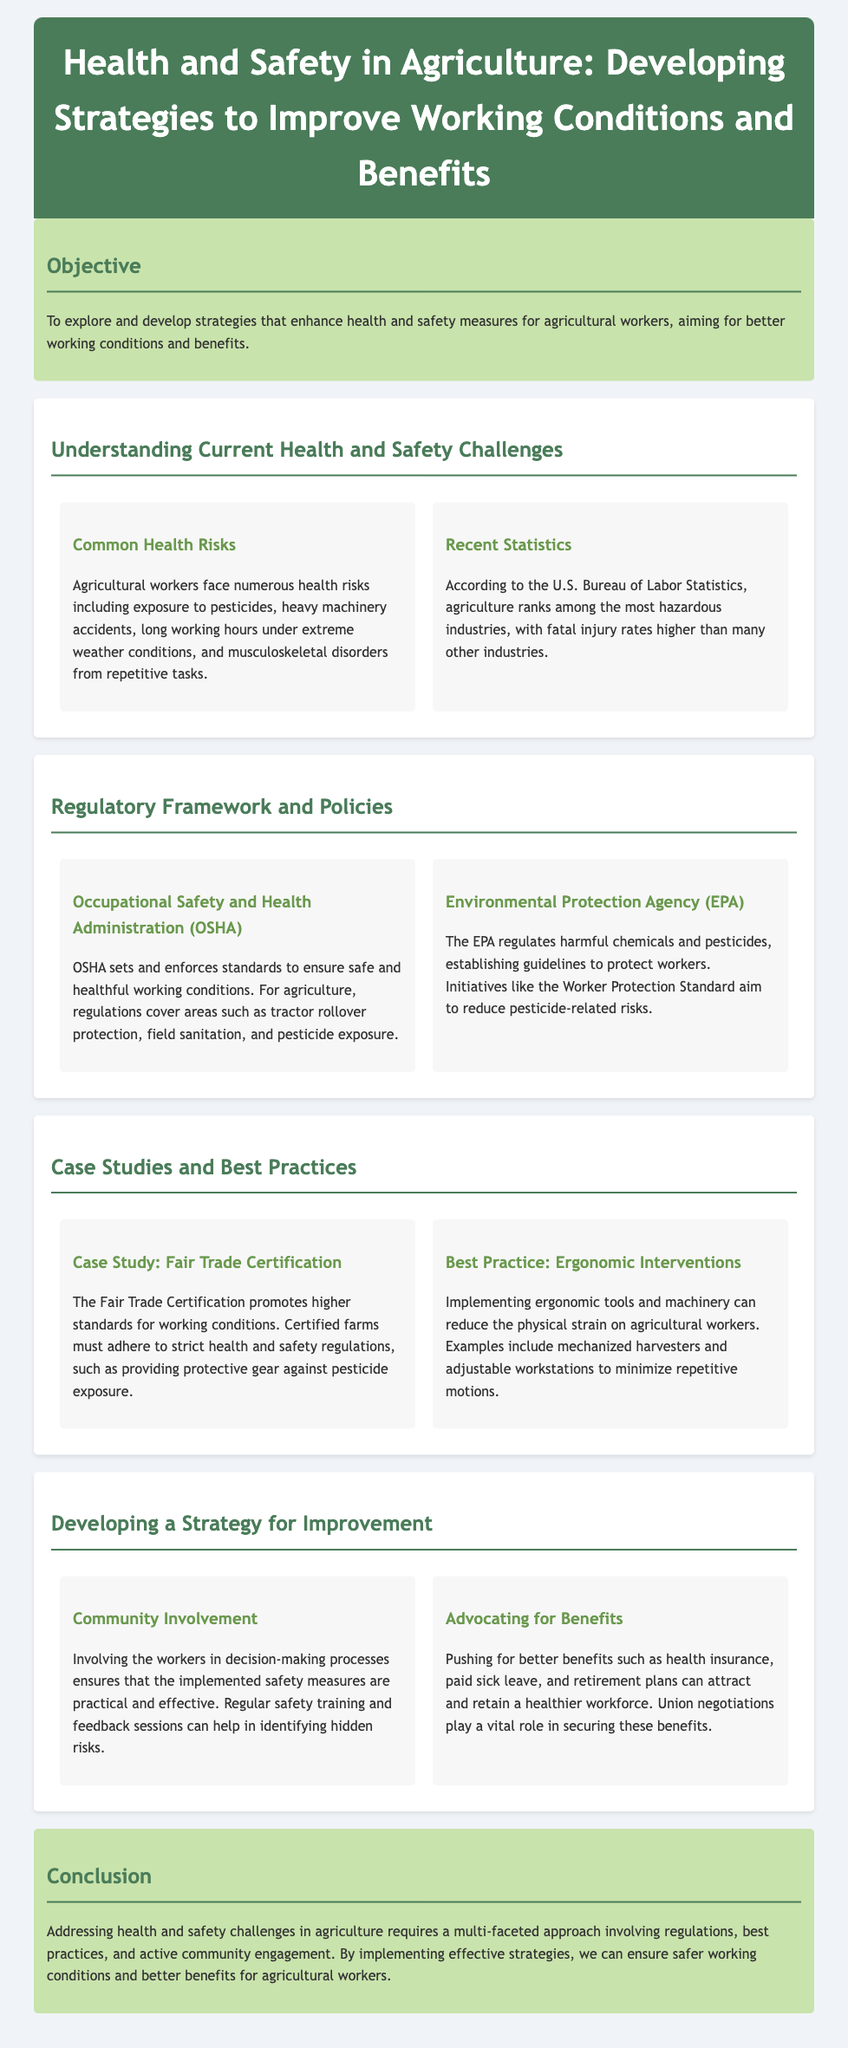What is the main objective of the lesson plan? The objective is to explore and develop strategies that enhance health and safety measures for agricultural workers, aiming for better working conditions and benefits.
Answer: Enhancing health and safety measures What organization sets standards for safe working conditions in agriculture? OSHA is the organization that sets and enforces standards to ensure safe and healthful working conditions.
Answer: OSHA What are two common health risks faced by agricultural workers? The document mentions pesticides exposure and heavy machinery accidents as common health risks.
Answer: Pesticides, heavy machinery accidents What does the Fair Trade Certification promote? The Fair Trade Certification promotes higher standards for working conditions, including safety regulations such as protective gear against pesticide exposure.
Answer: Higher standards for working conditions How can community involvement enhance health and safety measures? Involving workers in decision-making processes ensures practical and effective implementation of safety measures.
Answer: Practical and effective implementation Name one benefit that can help attract a healthier workforce. The document states that health insurance is one benefit that can help attract and retain a healthier workforce.
Answer: Health insurance What regulatory body establishes guidelines to protect agricultural workers from harmful chemicals? The Environmental Protection Agency (EPA) establishes guidelines to protect workers from harmful chemicals.
Answer: EPA What is one best practice mentioned for reducing physical strain on agricultural workers? Implementing ergonomic tools and machinery is a best practice mentioned to reduce physical strain.
Answer: Ergonomic tools and machinery What multi-faceted approach is required to address health and safety challenges in agriculture? The conclusion states that a multi-faceted approach involving regulations, best practices, and active community engagement is required.
Answer: Regulations, best practices, community engagement 